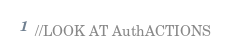Convert code to text. <code><loc_0><loc_0><loc_500><loc_500><_JavaScript_>//LOOK AT AuthACTIONS




</code> 